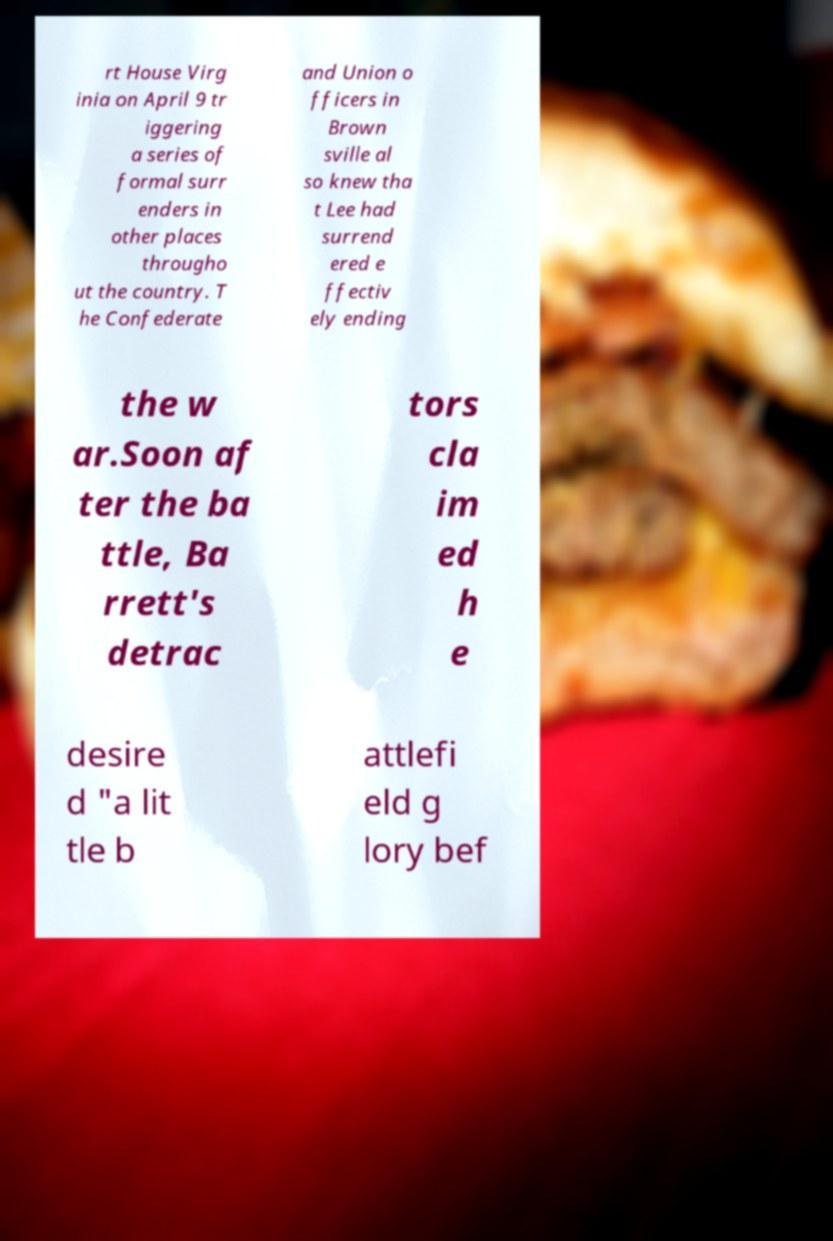Could you assist in decoding the text presented in this image and type it out clearly? rt House Virg inia on April 9 tr iggering a series of formal surr enders in other places througho ut the country. T he Confederate and Union o fficers in Brown sville al so knew tha t Lee had surrend ered e ffectiv ely ending the w ar.Soon af ter the ba ttle, Ba rrett's detrac tors cla im ed h e desire d "a lit tle b attlefi eld g lory bef 